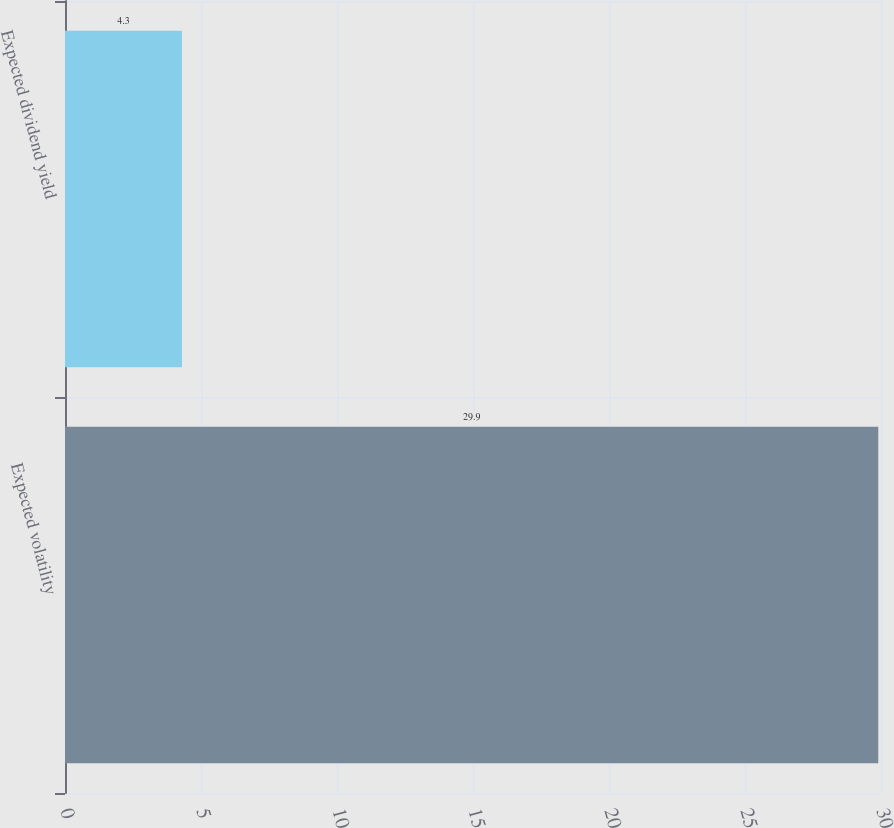<chart> <loc_0><loc_0><loc_500><loc_500><bar_chart><fcel>Expected volatility<fcel>Expected dividend yield<nl><fcel>29.9<fcel>4.3<nl></chart> 